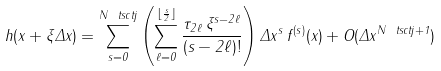<formula> <loc_0><loc_0><loc_500><loc_500>h ( x + \xi \Delta x ) = \sum _ { s = 0 } ^ { N _ { \ } t s c { t j } } \left ( \sum _ { \ell = 0 } ^ { \lfloor \frac { s } { 2 } \rfloor } \frac { \tau _ { 2 \ell } \, \xi ^ { s - 2 \ell } } { ( s - 2 \ell ) ! } \right ) \Delta x ^ { s } \, f ^ { ( s ) } ( x ) + O ( \Delta x ^ { N _ { \ } t s c { t j } + 1 } )</formula> 